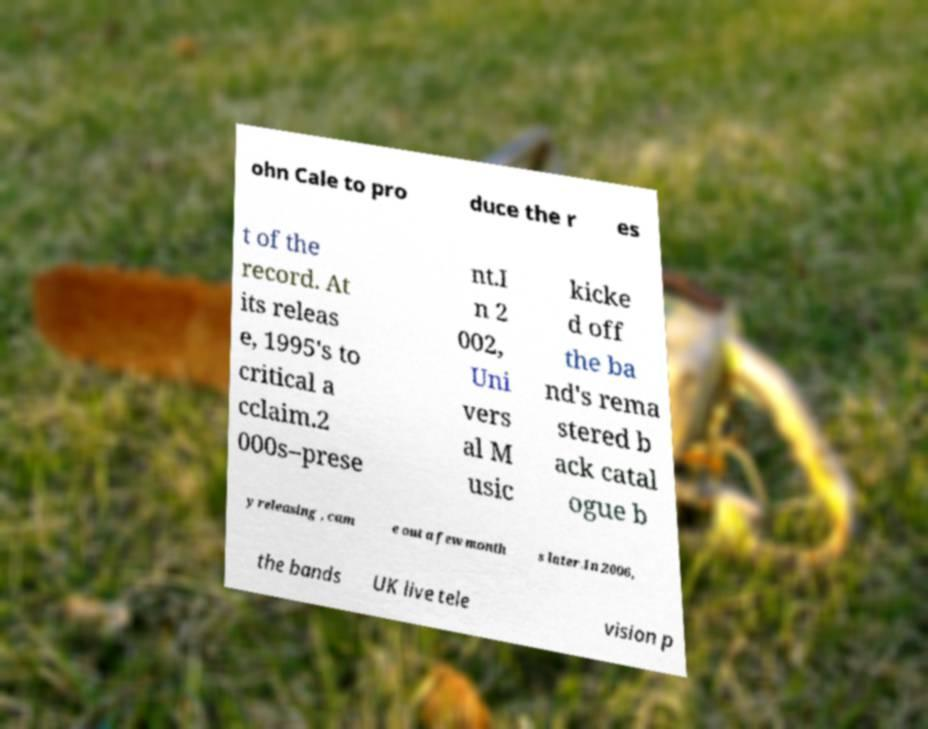What messages or text are displayed in this image? I need them in a readable, typed format. ohn Cale to pro duce the r es t of the record. At its releas e, 1995's to critical a cclaim.2 000s–prese nt.I n 2 002, Uni vers al M usic kicke d off the ba nd's rema stered b ack catal ogue b y releasing , cam e out a few month s later.In 2006, the bands UK live tele vision p 